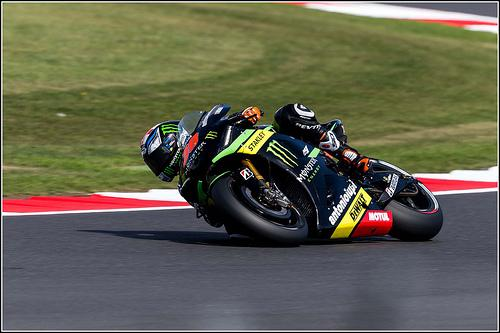Count the number of short green and brown grass patches mentioned in the image. There are 10 short green and brown grass patches in the image. What protective gear is the person riding the motorcycle wearing? The person is wearing a motorcycle helmet and orange gloves. Analyze the sentiment conveyed in the image. The sentiment conveyed is excitement and thrill as a person rides a motorcycle during a race. In the context of this image, how would you describe the condition of the road? The road in this image is a smooth, black cement road. Identify and describe an object in the image that seems to be interacting with another object. The motorcycle rider is interacting with the handlebar, holding on to it while navigating the race track. Provide a description of the boundaries surrounding the racing track. The track has red and white lanes acting as boundaries. Identify the primary object in the image and describe its action. The main object is a motorcycle, which is being ridden at a low height by a person during a race. Describe some of the logos and messages visible on different objects in the image. There are logos of Monster Energy, Motul, and Dewalt as well as a message saying "stakley" on various objects in the image. Explain the main activity happening in the image. A person is participating in a motorcycle race, leaning over to turn, wearing a helmet and orange gloves. What are the notable aspects of the motorcycle? Riding low, leaning towards the ground, Monster Energy Drink logo, Stakley message, Motul logo, and yellow Dewalt logo What type of grass can be seen in the image? Short green and brown grass Determine the type and condition of the road based on the image. Smooth black cement road Choose the motorcycle rider's glove color out of these options: Green, Orange, Blue, Red. Orange Which brand logo is visible on the side of the motorcycle helmet? Monster logo What is the color of both wheels on the motorcycle? Black What is the motorcyclist wearing on their head? A helmet Find the red and white elements surrounding the track. Boundary lanes What message is written on the motorcycle, and which logo is also present on it or the helmet? Stakley, Monster Energy Drink logo, and Motul logo Describe the track's surroundings. Green grass infield, red and white boundary, and short green grass on the lawn What activity can you deduce from the position of the motorcycle rider? Racing in a track Locate the logos of two companies featured in the image. Monster Energy Drink and Motul Identify the main subject participating in a race. A person riding a motorcycle Identify which type of boundary is surrounding the track. Red and white boundary Which of these statements best describes the road: Rough gray cement, smooth black cement, or bumpy white cement? Smooth black cement Describe the scene happening on the track. A person is leaning over on a motorcycle to turn during a race on a track surrounded by a red and white boundary and green grass infield. Infer the emotion of the person riding the motorcycle. Cannot infer emotion, as the face is not visible What material are the motorcycle tires made of? Rubber Choose the correct description of the rider's gloves: Orange with blue spots, plain orange, red with black stripes, green with white spots. Plain orange 